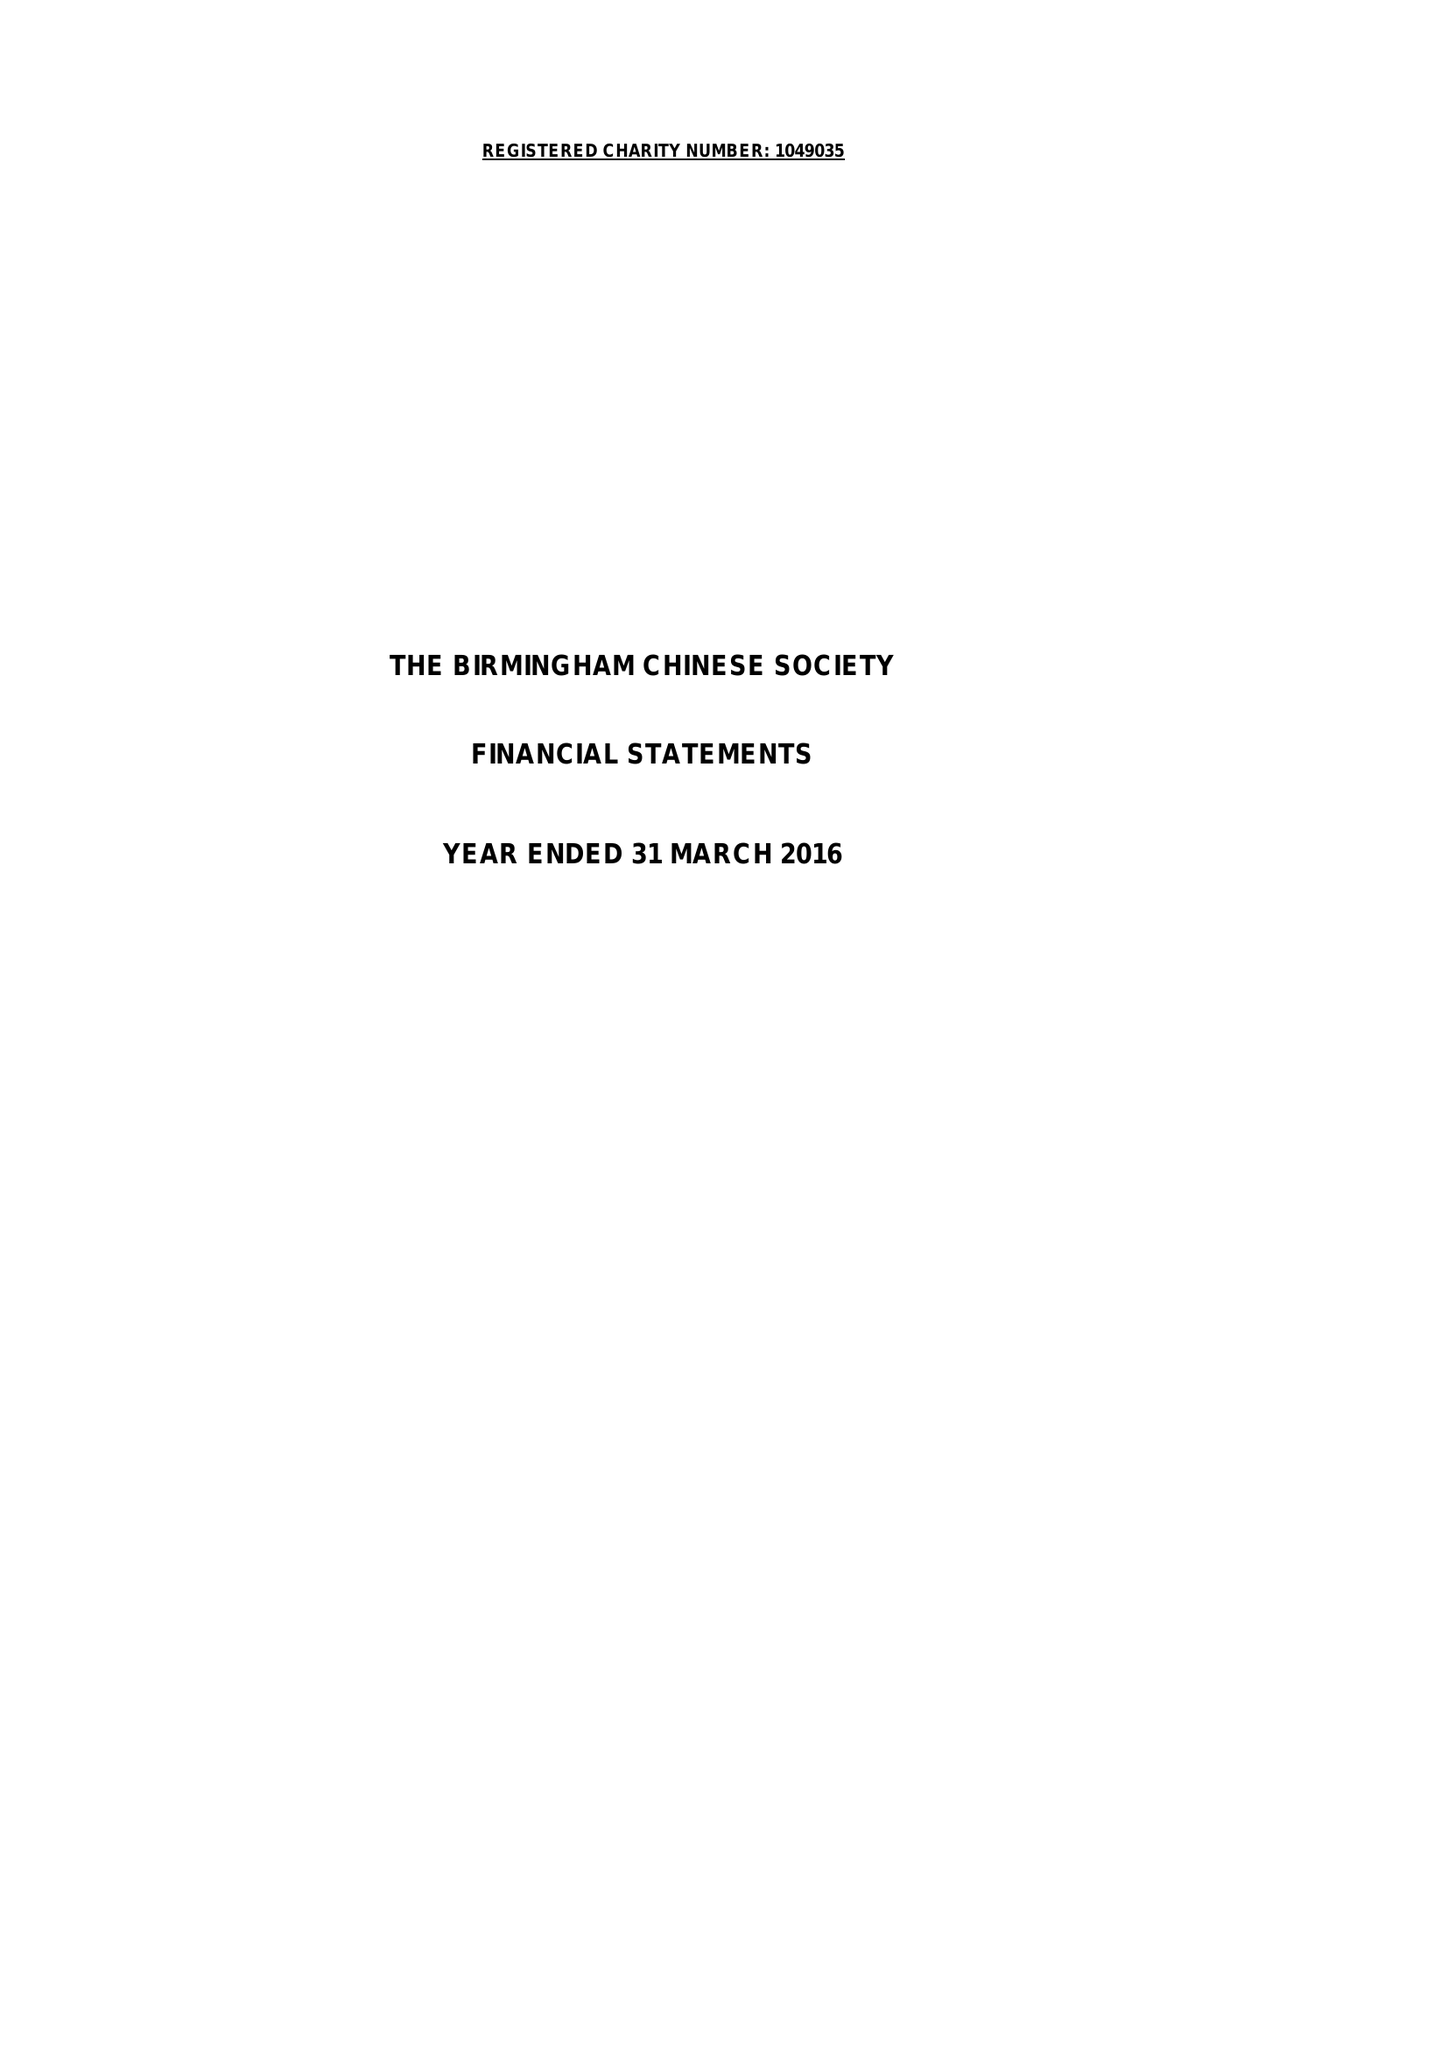What is the value for the charity_number?
Answer the question using a single word or phrase. 1049035 